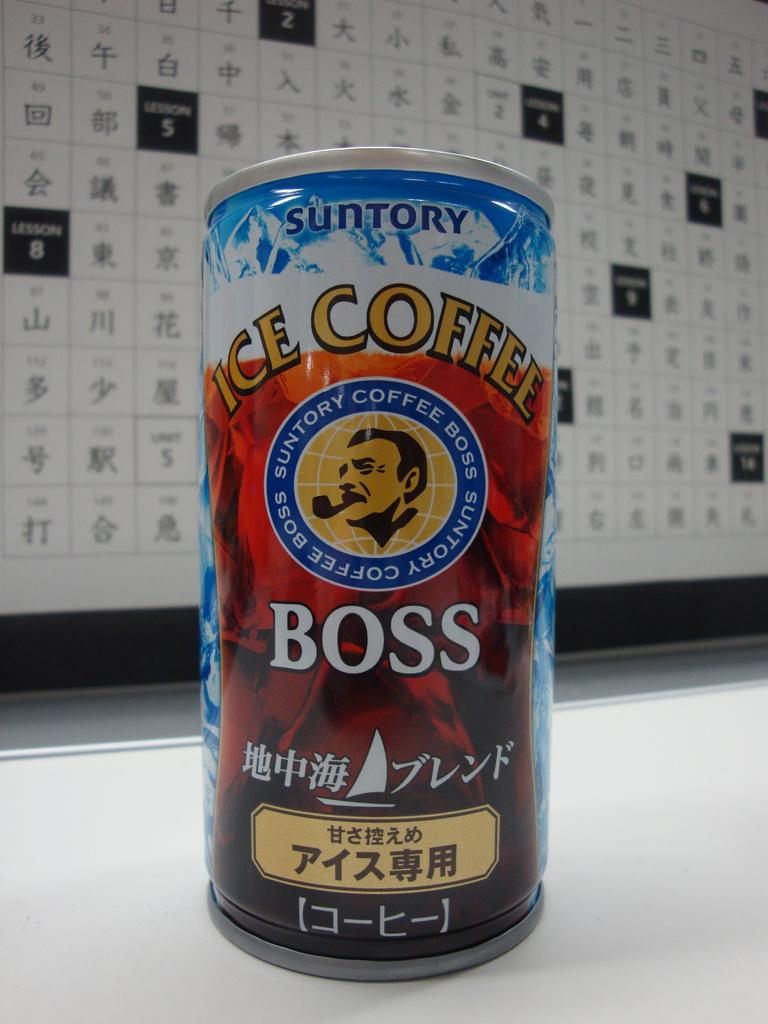Provide a one-sentence caption for the provided image. A can of iced coffee called Boss sitting in front of a board of Japanese letters. 